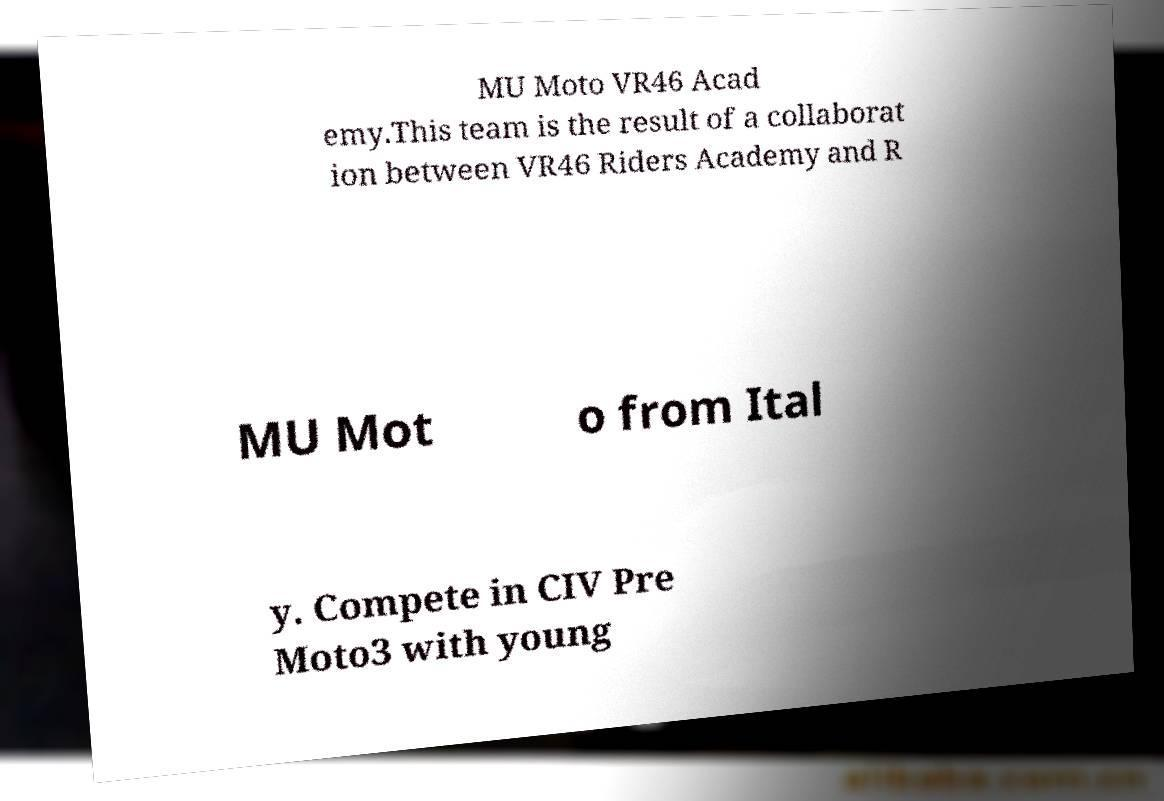Please identify and transcribe the text found in this image. MU Moto VR46 Acad emy.This team is the result of a collaborat ion between VR46 Riders Academy and R MU Mot o from Ital y. Compete in CIV Pre Moto3 with young 